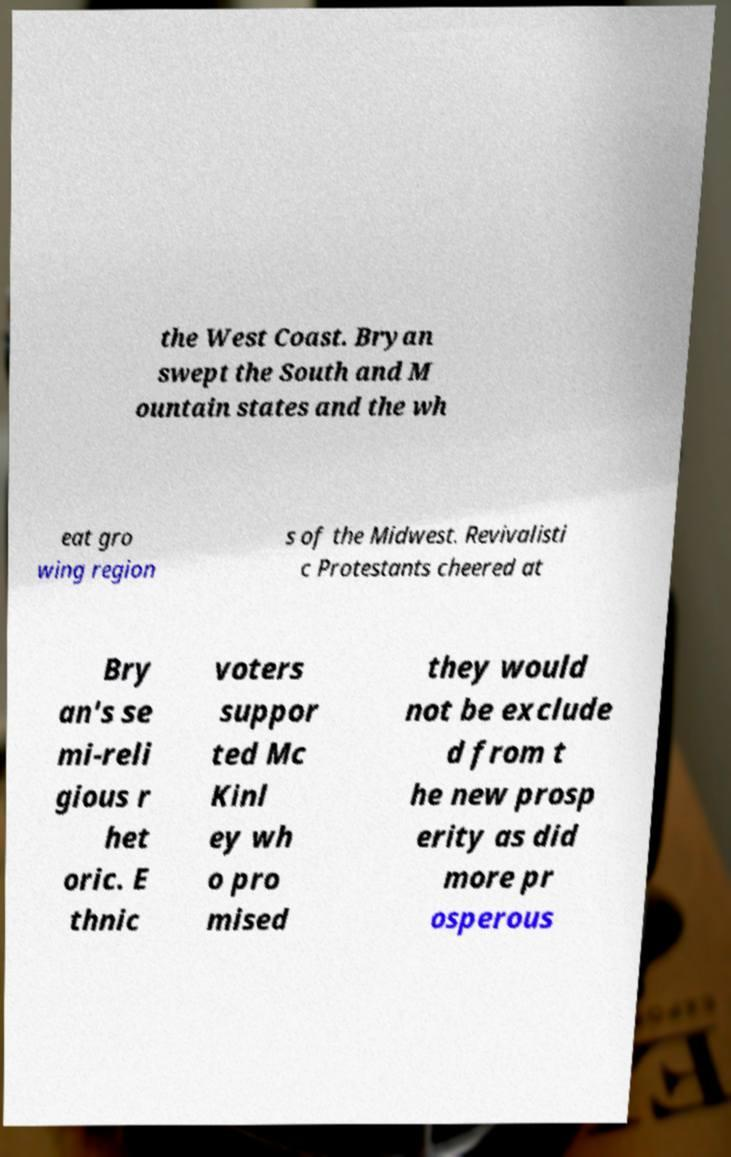Can you read and provide the text displayed in the image?This photo seems to have some interesting text. Can you extract and type it out for me? the West Coast. Bryan swept the South and M ountain states and the wh eat gro wing region s of the Midwest. Revivalisti c Protestants cheered at Bry an's se mi-reli gious r het oric. E thnic voters suppor ted Mc Kinl ey wh o pro mised they would not be exclude d from t he new prosp erity as did more pr osperous 